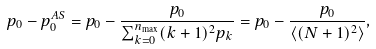Convert formula to latex. <formula><loc_0><loc_0><loc_500><loc_500>p _ { 0 } - p _ { 0 } ^ { A S } = p _ { 0 } - \frac { p _ { 0 } } { \sum _ { k = 0 } ^ { n _ { \max } } ( k + 1 ) ^ { 2 } p _ { k } } = p _ { 0 } - \frac { p _ { 0 } } { \langle ( N + 1 ) ^ { 2 } \rangle } ,</formula> 